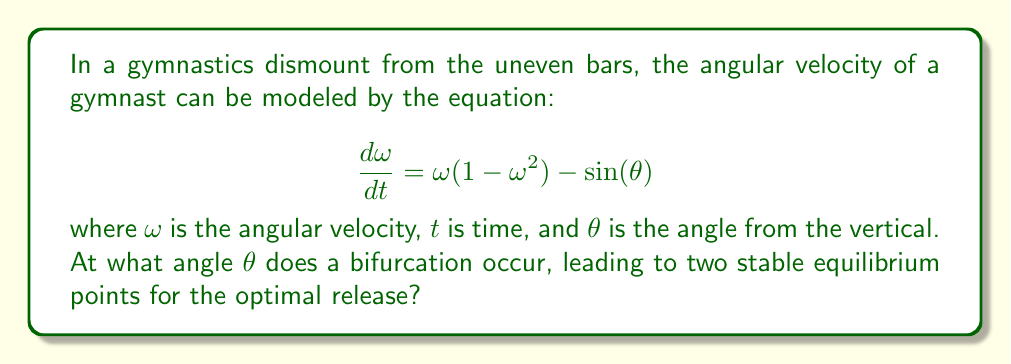Provide a solution to this math problem. To determine the bifurcation point, we need to follow these steps:

1) First, find the equilibrium points by setting $\frac{d\omega}{dt} = 0$:

   $$\omega(1 - \omega^2) - \sin(\theta) = 0$$

2) For a bifurcation to occur, we need three solutions to this equation (two stable, one unstable). This happens when the equation is tangent to the $\omega$-axis.

3) Rewrite the equation as:

   $$\omega^3 - \omega + \sin(\theta) = 0$$

4) For this cubic equation to have three roots, its discriminant must be zero. The discriminant for a cubic equation $ax^3 + bx^2 + cx + d = 0$ is:

   $$\Delta = 18abcd - 4b^3d + b^2c^2 - 4ac^3 - 27a^2d^2$$

5) In our case, $a=1$, $b=0$, $c=-1$, and $d=\sin(\theta)$. Substituting:

   $$\Delta = -4(-1)^3 - 27(1)^2(\sin(\theta))^2 = -4 - 27\sin^2(\theta) = 0$$

6) Solve this equation:

   $$-4 - 27\sin^2(\theta) = 0$$
   $$27\sin^2(\theta) = -4$$
   $$\sin^2(\theta) = \frac{4}{27}$$
   $$\sin(\theta) = \pm\frac{2\sqrt{3}}{9}$$

7) Since we're dealing with an angle, we take the positive solution:

   $$\theta = \arcsin(\frac{2\sqrt{3}}{9})$$

This angle represents the bifurcation point where the system transitions from one stable equilibrium to two stable equilibria, providing the optimal release point for the gymnast.
Answer: $\theta = \arcsin(\frac{2\sqrt{3}}{9}) \approx 0.3398$ radians or $19.47°$ 